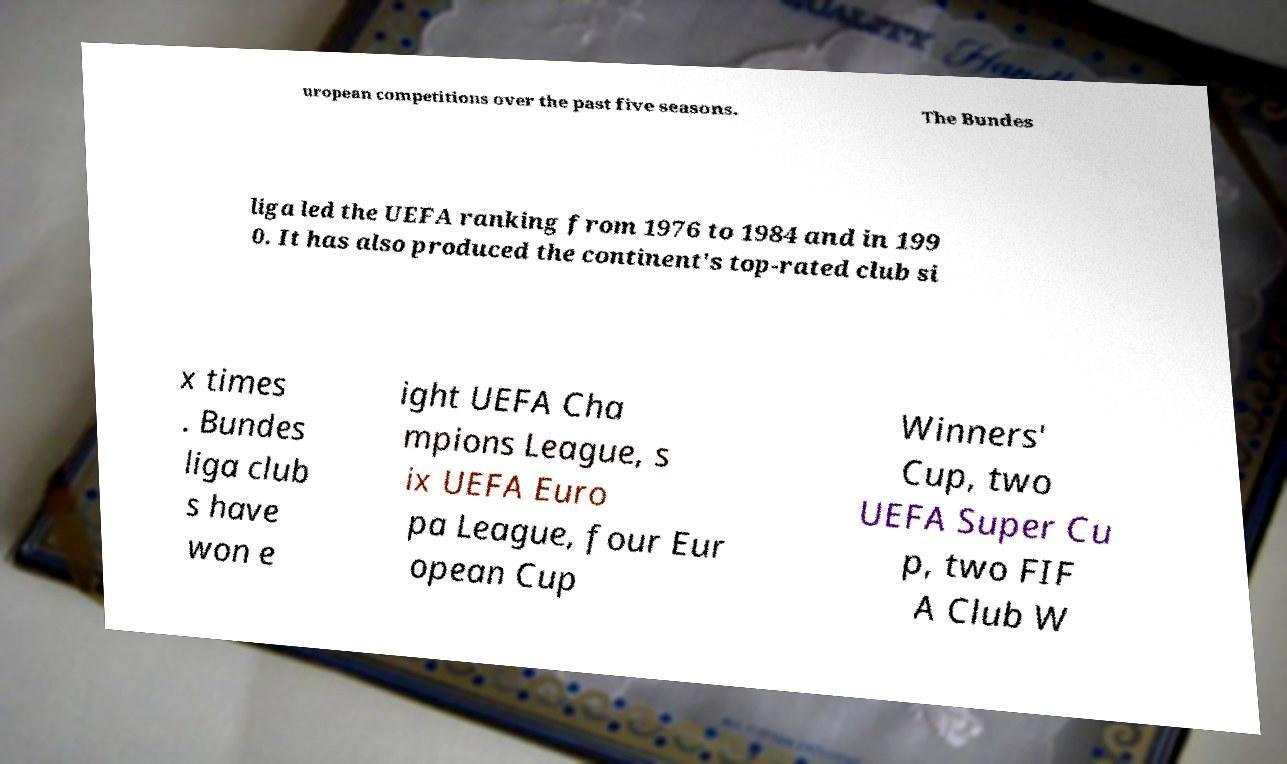Please identify and transcribe the text found in this image. uropean competitions over the past five seasons. The Bundes liga led the UEFA ranking from 1976 to 1984 and in 199 0. It has also produced the continent's top-rated club si x times . Bundes liga club s have won e ight UEFA Cha mpions League, s ix UEFA Euro pa League, four Eur opean Cup Winners' Cup, two UEFA Super Cu p, two FIF A Club W 